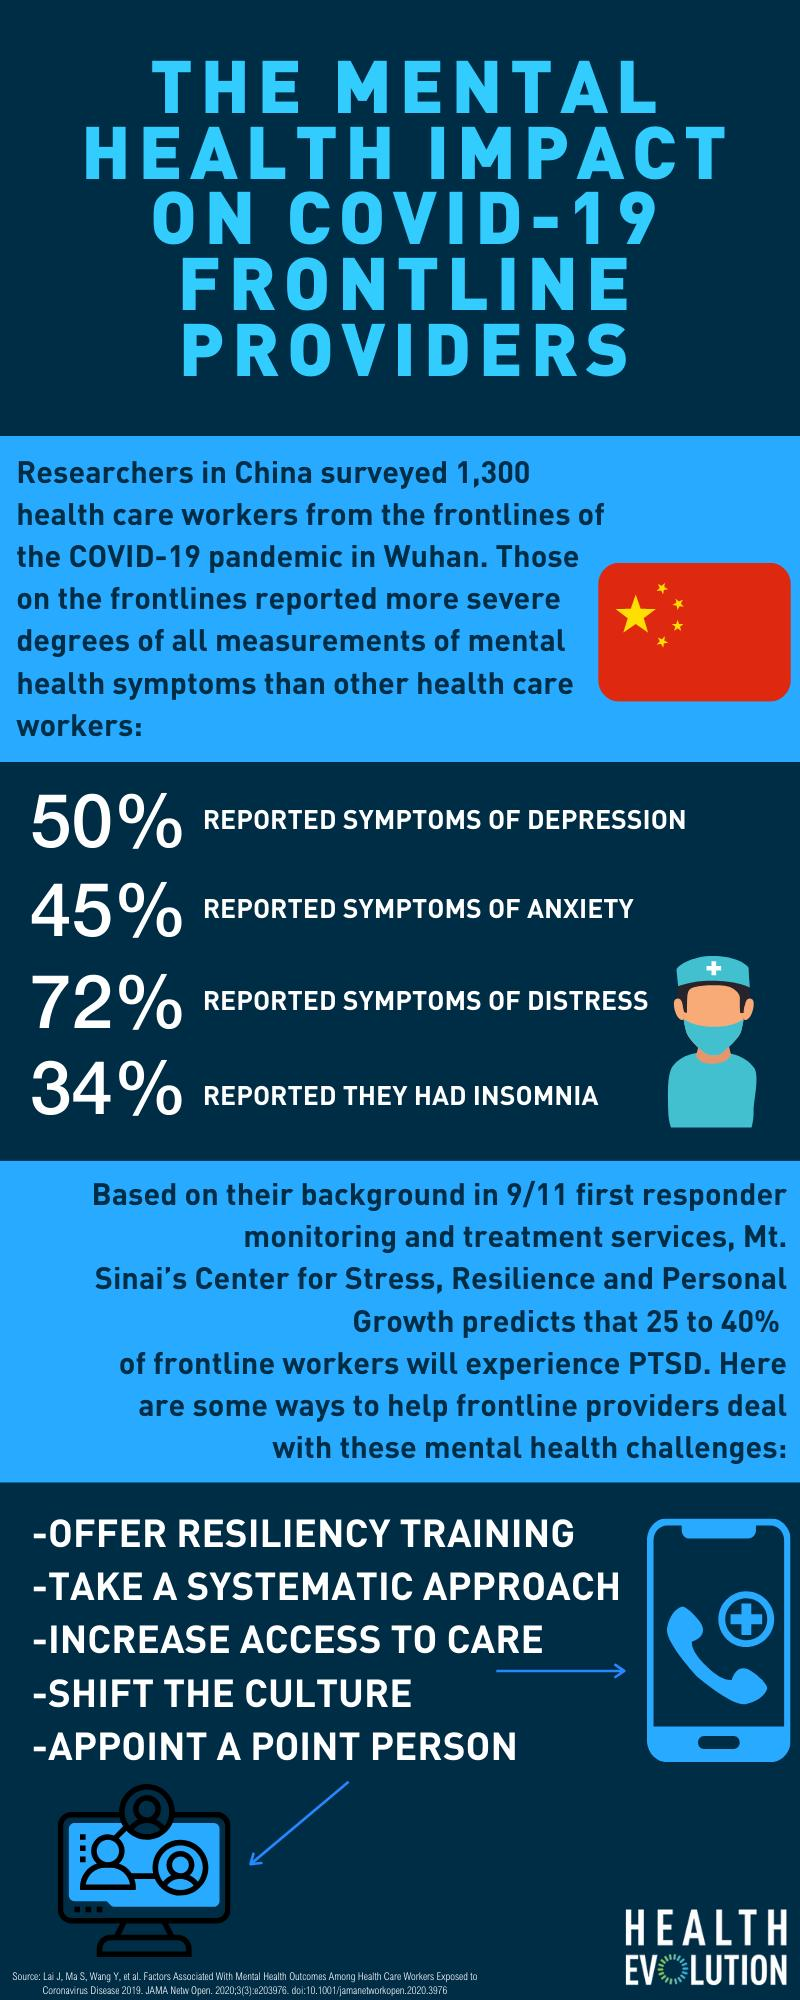Draw attention to some important aspects in this diagram. According to a survey, 66% of individuals do not experience any symptoms of insomnia. According to a recent study, over half of individuals with depression do not exhibit any symptoms. According to the data, a significant percentage of people, 28%, report having no symptoms of distress. According to a recent study, 55% of individuals do not exhibit any symptoms of anxiety. 